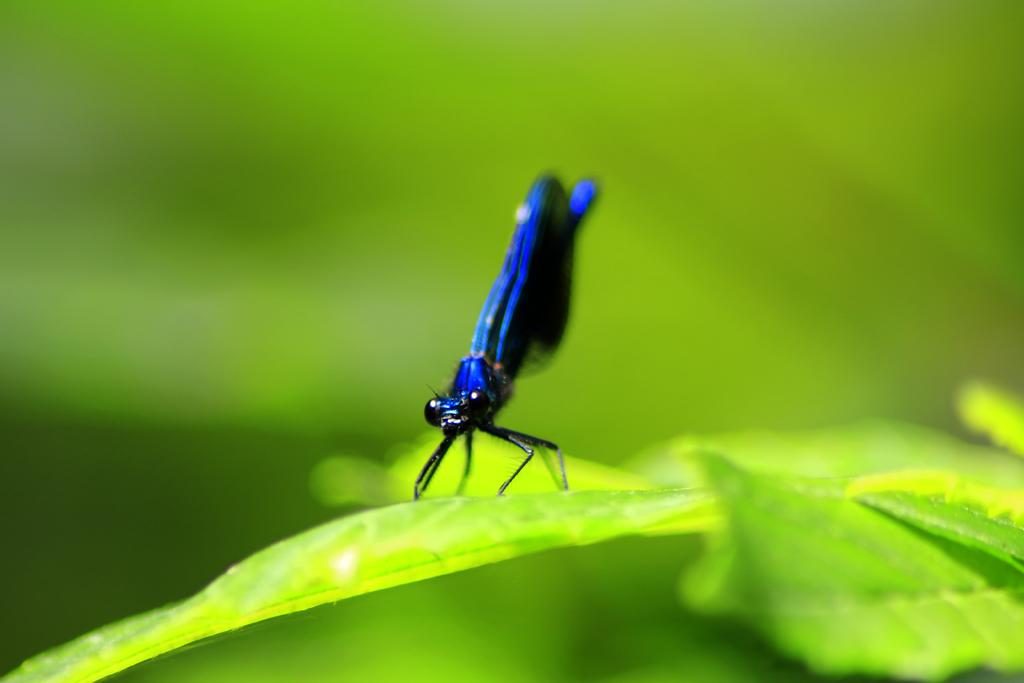What is present on the leaf in the image? There is an insect on a leaf in the image. Can you describe the background of the image? The background of the image is blurry. What type of comb is the boy using to swim in the image? There is no boy or swimming activity present in the image; it features an insect on a leaf with a blurry background. 